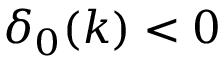<formula> <loc_0><loc_0><loc_500><loc_500>\delta _ { 0 } ( k ) < 0</formula> 